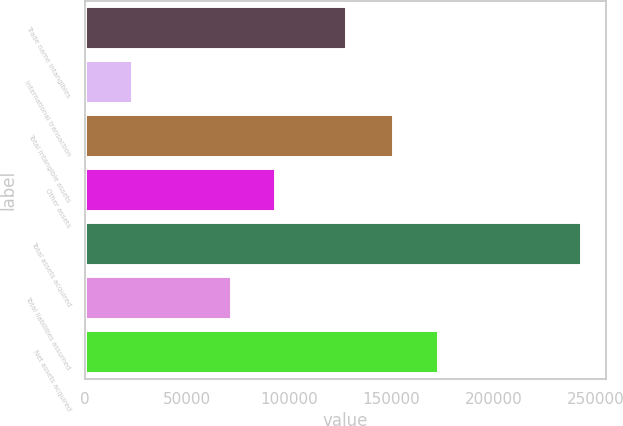Convert chart to OTSL. <chart><loc_0><loc_0><loc_500><loc_500><bar_chart><fcel>Trade name intangibles<fcel>International transaction<fcel>Total intangible assets<fcel>Other assets<fcel>Total assets acquired<fcel>Total liabilities assumed<fcel>Net assets acquired<nl><fcel>127980<fcel>23047<fcel>151027<fcel>93287.4<fcel>242701<fcel>71322<fcel>172992<nl></chart> 